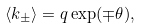Convert formula to latex. <formula><loc_0><loc_0><loc_500><loc_500>\langle k _ { \pm } \rangle = q \exp ( \mp \theta ) ,</formula> 